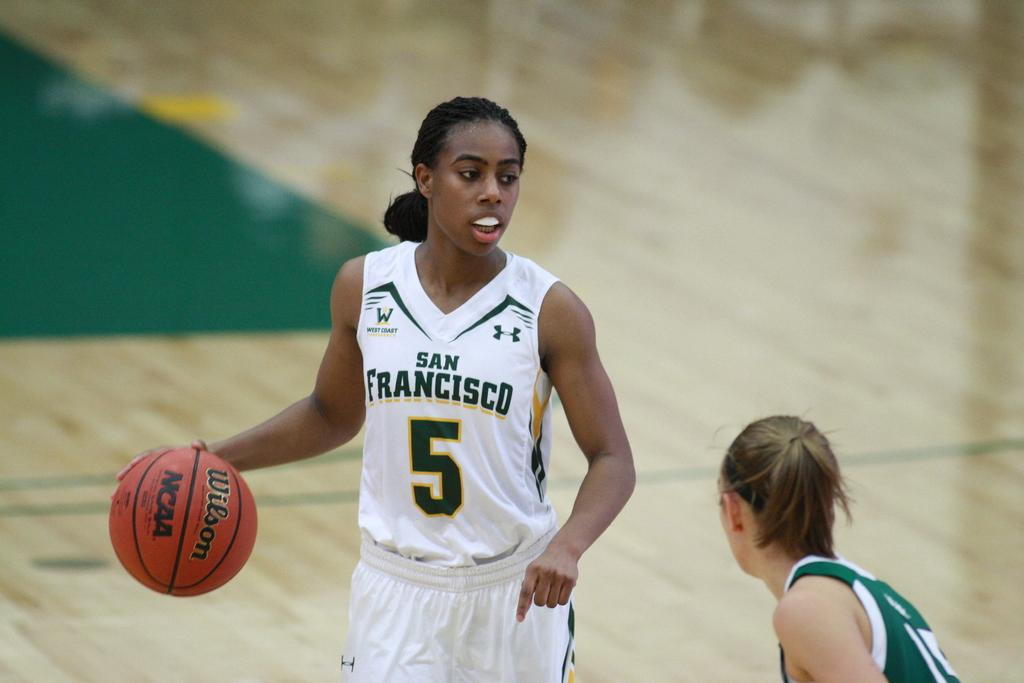<image>
Share a concise interpretation of the image provided. The female basketball player in possession of the ball is number 5 from San Francisco. 